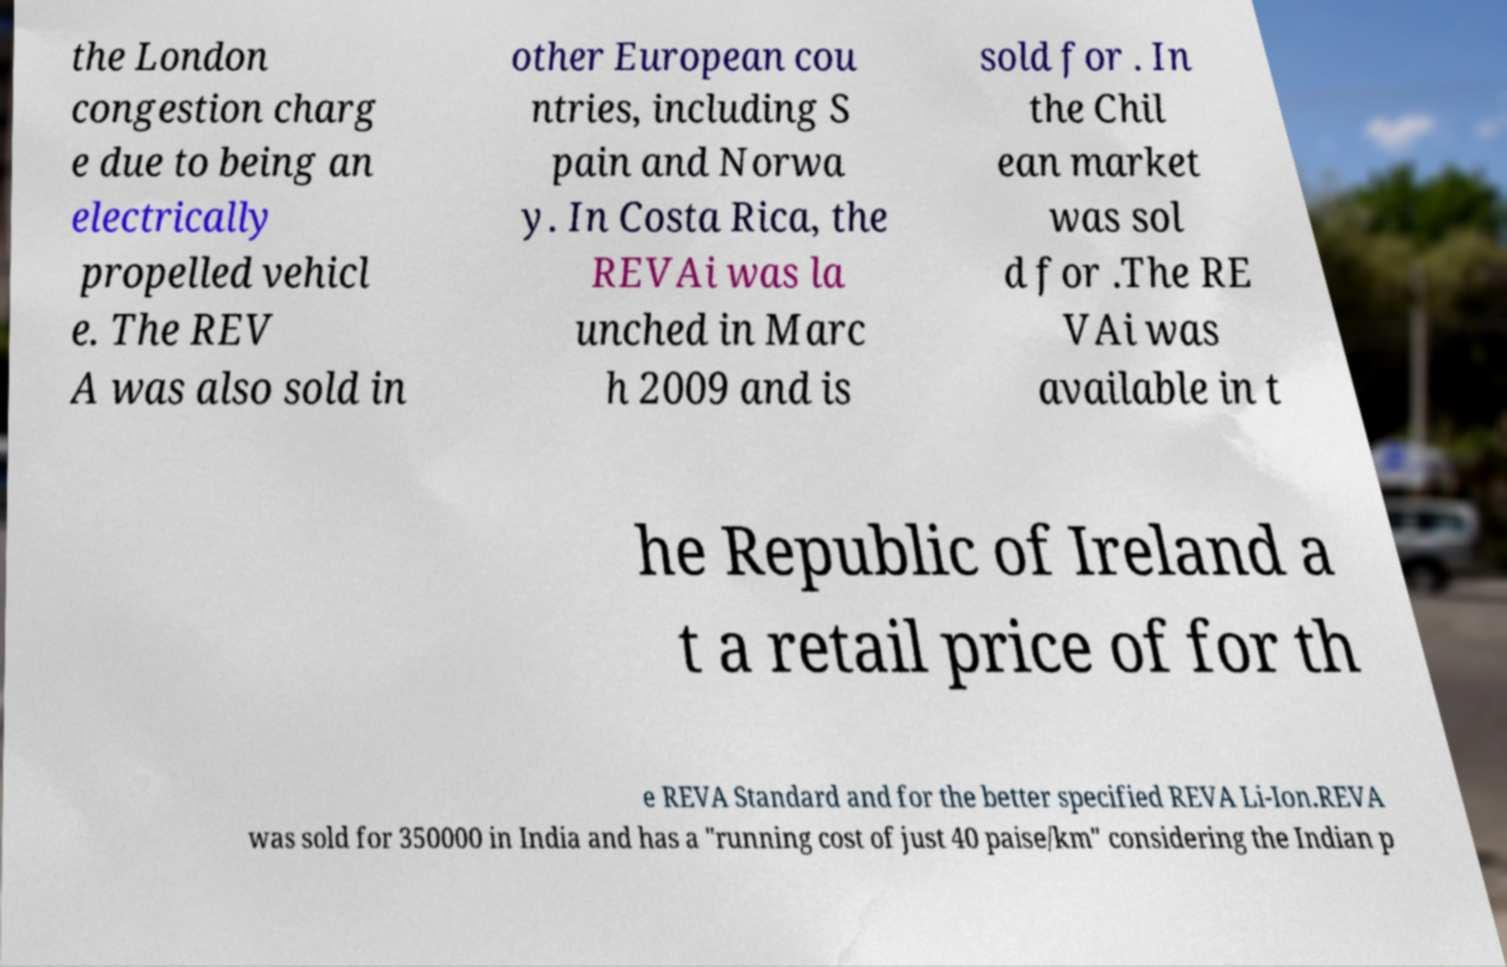Please read and relay the text visible in this image. What does it say? the London congestion charg e due to being an electrically propelled vehicl e. The REV A was also sold in other European cou ntries, including S pain and Norwa y. In Costa Rica, the REVAi was la unched in Marc h 2009 and is sold for . In the Chil ean market was sol d for .The RE VAi was available in t he Republic of Ireland a t a retail price of for th e REVA Standard and for the better specified REVA Li-Ion.REVA was sold for 350000 in India and has a "running cost of just 40 paise/km" considering the Indian p 